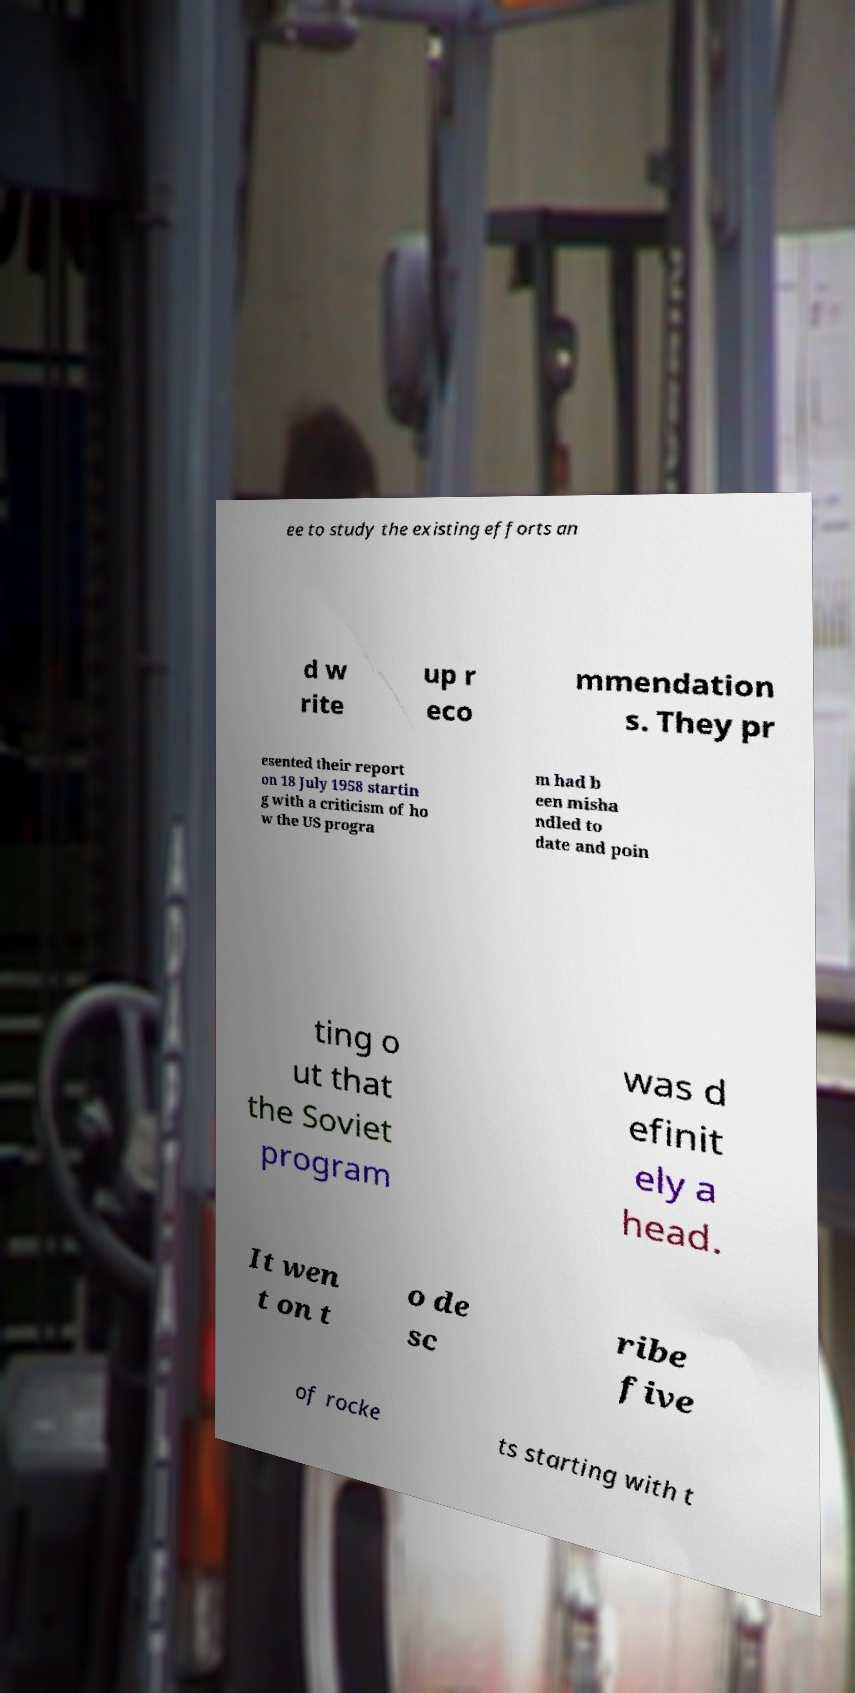Could you assist in decoding the text presented in this image and type it out clearly? ee to study the existing efforts an d w rite up r eco mmendation s. They pr esented their report on 18 July 1958 startin g with a criticism of ho w the US progra m had b een misha ndled to date and poin ting o ut that the Soviet program was d efinit ely a head. It wen t on t o de sc ribe five of rocke ts starting with t 